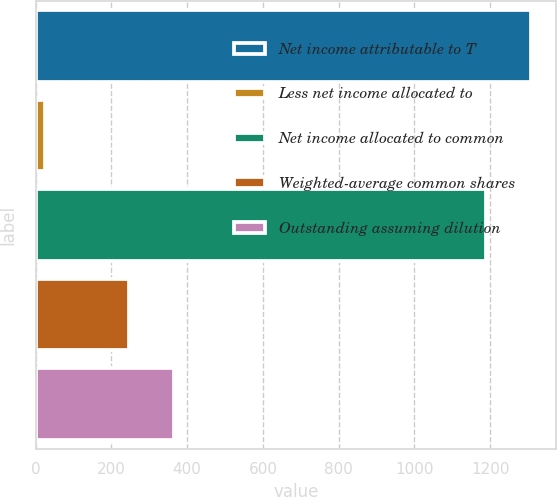Convert chart. <chart><loc_0><loc_0><loc_500><loc_500><bar_chart><fcel>Net income attributable to T<fcel>Less net income allocated to<fcel>Net income allocated to common<fcel>Weighted-average common shares<fcel>Outstanding assuming dilution<nl><fcel>1308.45<fcel>25.5<fcel>1189.5<fcel>245.5<fcel>364.45<nl></chart> 